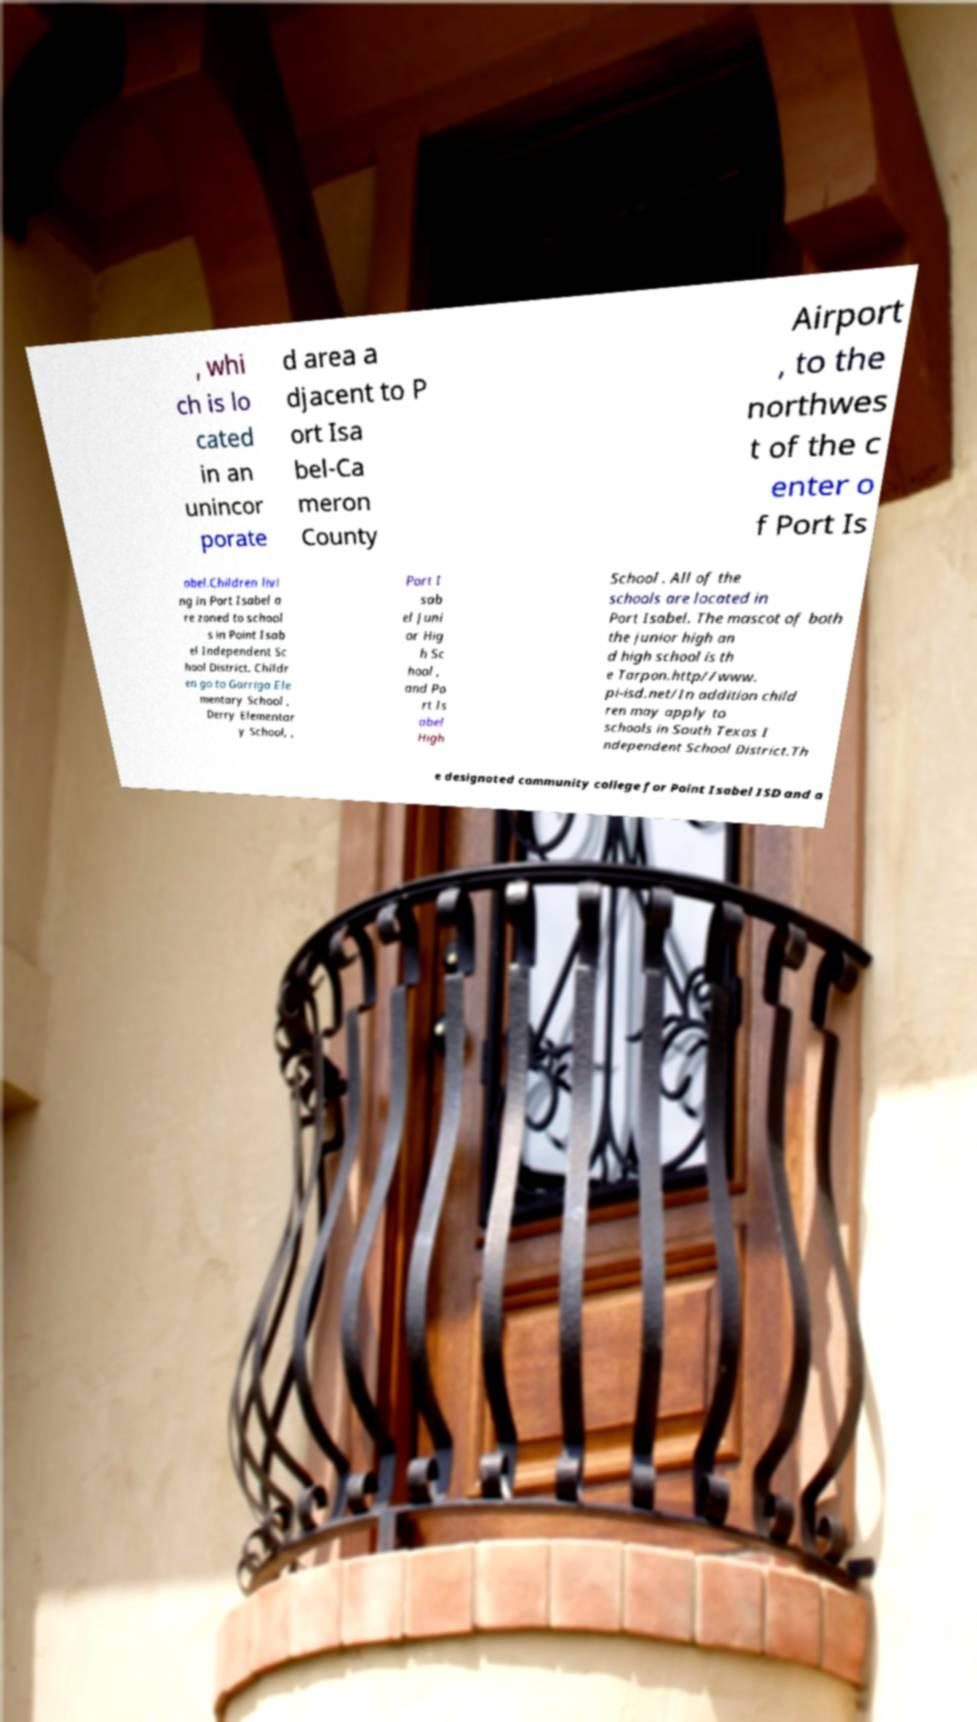Can you accurately transcribe the text from the provided image for me? , whi ch is lo cated in an unincor porate d area a djacent to P ort Isa bel-Ca meron County Airport , to the northwes t of the c enter o f Port Is abel.Children livi ng in Port Isabel a re zoned to school s in Point Isab el Independent Sc hool District. Childr en go to Garriga Ele mentary School , Derry Elementar y School, , Port I sab el Juni or Hig h Sc hool , and Po rt Is abel High School . All of the schools are located in Port Isabel. The mascot of both the junior high an d high school is th e Tarpon.http//www. pi-isd.net/In addition child ren may apply to schools in South Texas I ndependent School District.Th e designated community college for Point Isabel ISD and a 